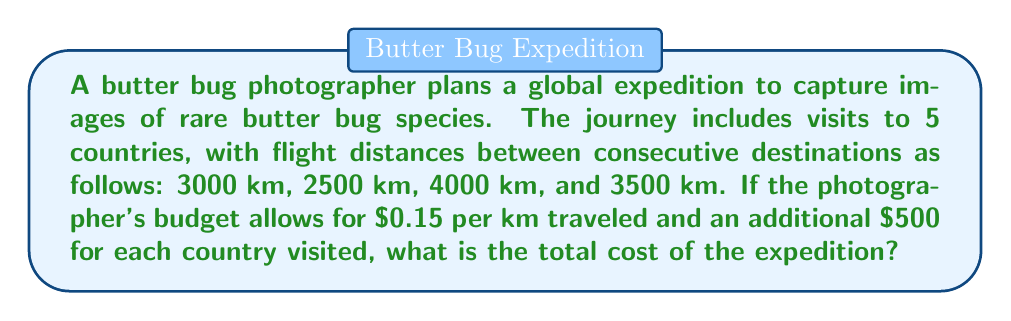Help me with this question. Let's break this problem down step-by-step:

1. Calculate the total distance traveled:
   $$\text{Total distance} = 3000 + 2500 + 4000 + 3500 = 13000 \text{ km}$$

2. Calculate the cost of travel based on distance:
   $$\text{Travel cost} = 13000 \text{ km} \times \$0.15/\text{km} = \$1950$$

3. Calculate the additional cost for visiting countries:
   $$\text{Country visit cost} = 5 \text{ countries} \times \$500/\text{country} = \$2500$$

4. Sum up the total cost:
   $$\text{Total cost} = \text{Travel cost} + \text{Country visit cost}$$
   $$\text{Total cost} = \$1950 + \$2500 = \$4450$$

Therefore, the total cost of the expedition is $4450.
Answer: $4450 